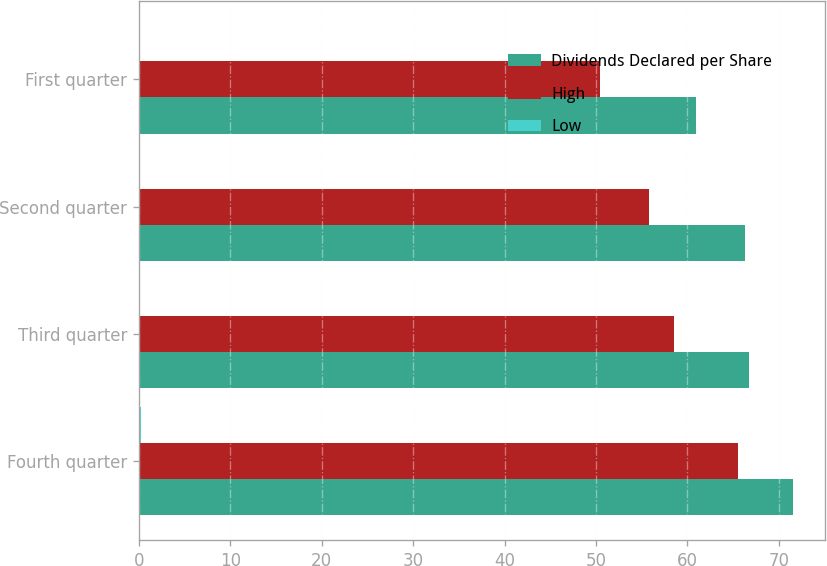Convert chart to OTSL. <chart><loc_0><loc_0><loc_500><loc_500><stacked_bar_chart><ecel><fcel>Fourth quarter<fcel>Third quarter<fcel>Second quarter<fcel>First quarter<nl><fcel>Dividends Declared per Share<fcel>71.53<fcel>66.8<fcel>66.33<fcel>61<nl><fcel>High<fcel>65.59<fcel>58.57<fcel>55.8<fcel>50.49<nl><fcel>Low<fcel>0.21<fcel>0.16<fcel>0.16<fcel>0.16<nl></chart> 